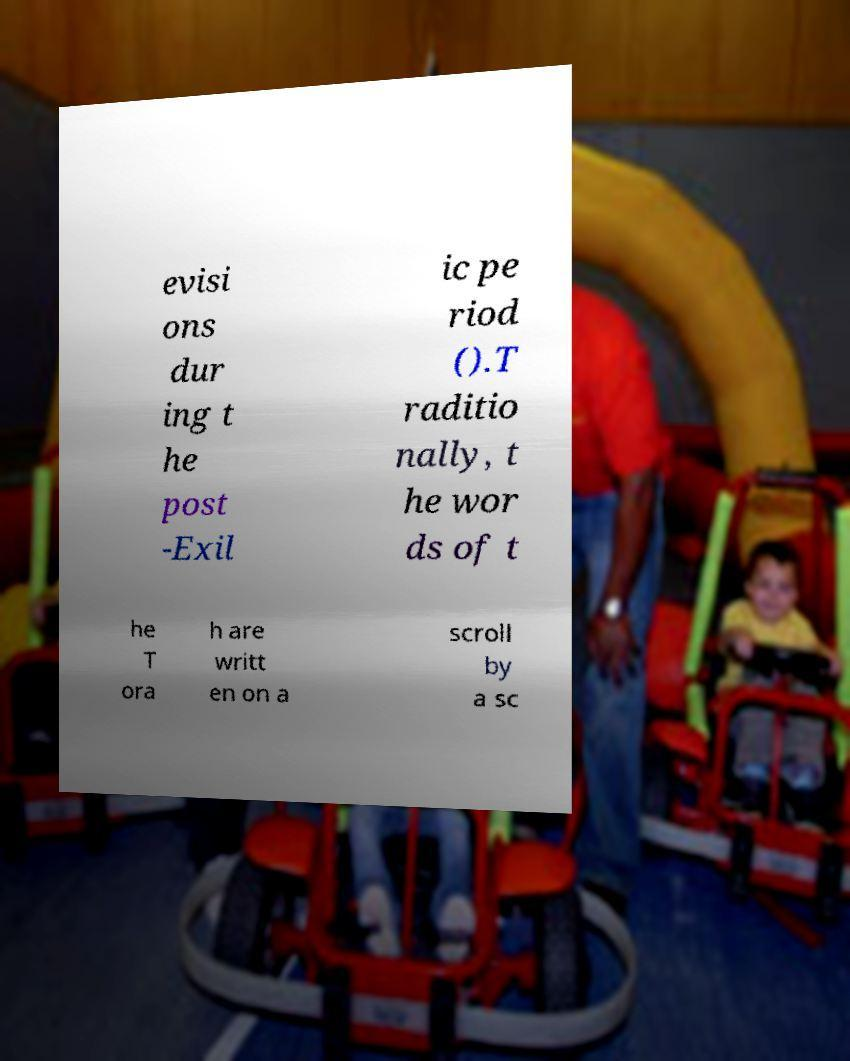What messages or text are displayed in this image? I need them in a readable, typed format. evisi ons dur ing t he post -Exil ic pe riod ().T raditio nally, t he wor ds of t he T ora h are writt en on a scroll by a sc 